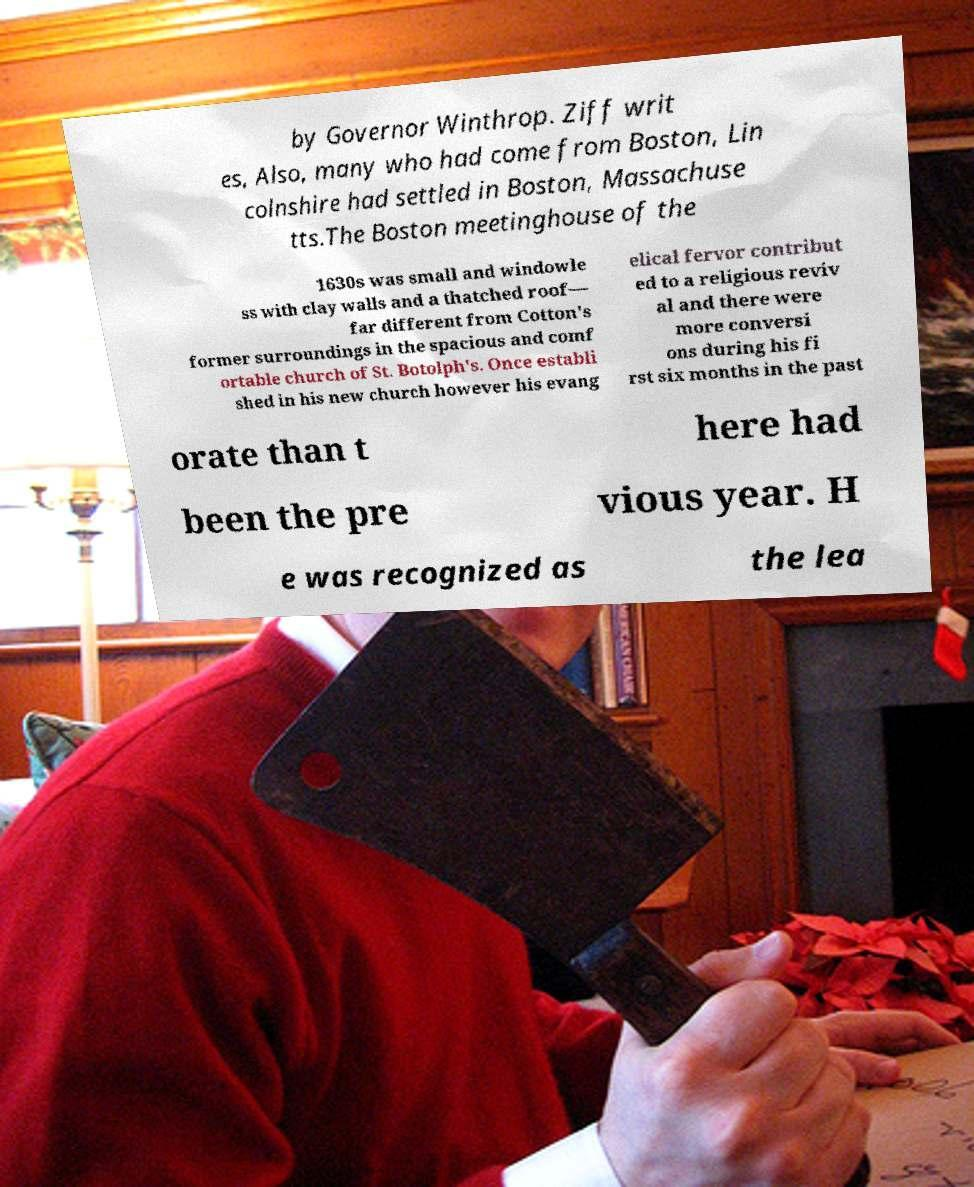There's text embedded in this image that I need extracted. Can you transcribe it verbatim? by Governor Winthrop. Ziff writ es, Also, many who had come from Boston, Lin colnshire had settled in Boston, Massachuse tts.The Boston meetinghouse of the 1630s was small and windowle ss with clay walls and a thatched roof— far different from Cotton's former surroundings in the spacious and comf ortable church of St. Botolph's. Once establi shed in his new church however his evang elical fervor contribut ed to a religious reviv al and there were more conversi ons during his fi rst six months in the past orate than t here had been the pre vious year. H e was recognized as the lea 